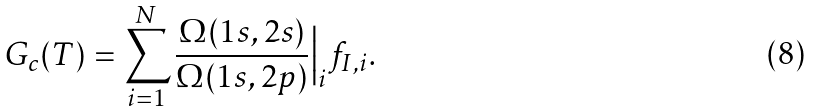<formula> <loc_0><loc_0><loc_500><loc_500>G _ { c } ( T ) = \sum _ { i = 1 } ^ { N } \frac { \Omega ( 1 s , 2 s ) } { \Omega ( 1 s , 2 p ) } \Big | _ { i } f _ { I , i } .</formula> 